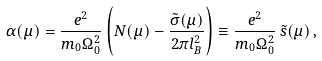Convert formula to latex. <formula><loc_0><loc_0><loc_500><loc_500>\alpha ( \mu ) = \frac { e ^ { 2 } } { m _ { 0 } \Omega _ { 0 } ^ { 2 } } \left ( N ( \mu ) - \frac { \tilde { \sigma } ( \mu ) } { 2 \pi l _ { B } ^ { 2 } } \right ) \equiv \frac { e ^ { 2 } } { m _ { 0 } \Omega _ { 0 } ^ { 2 } } \, \tilde { s } ( \mu ) \, ,</formula> 